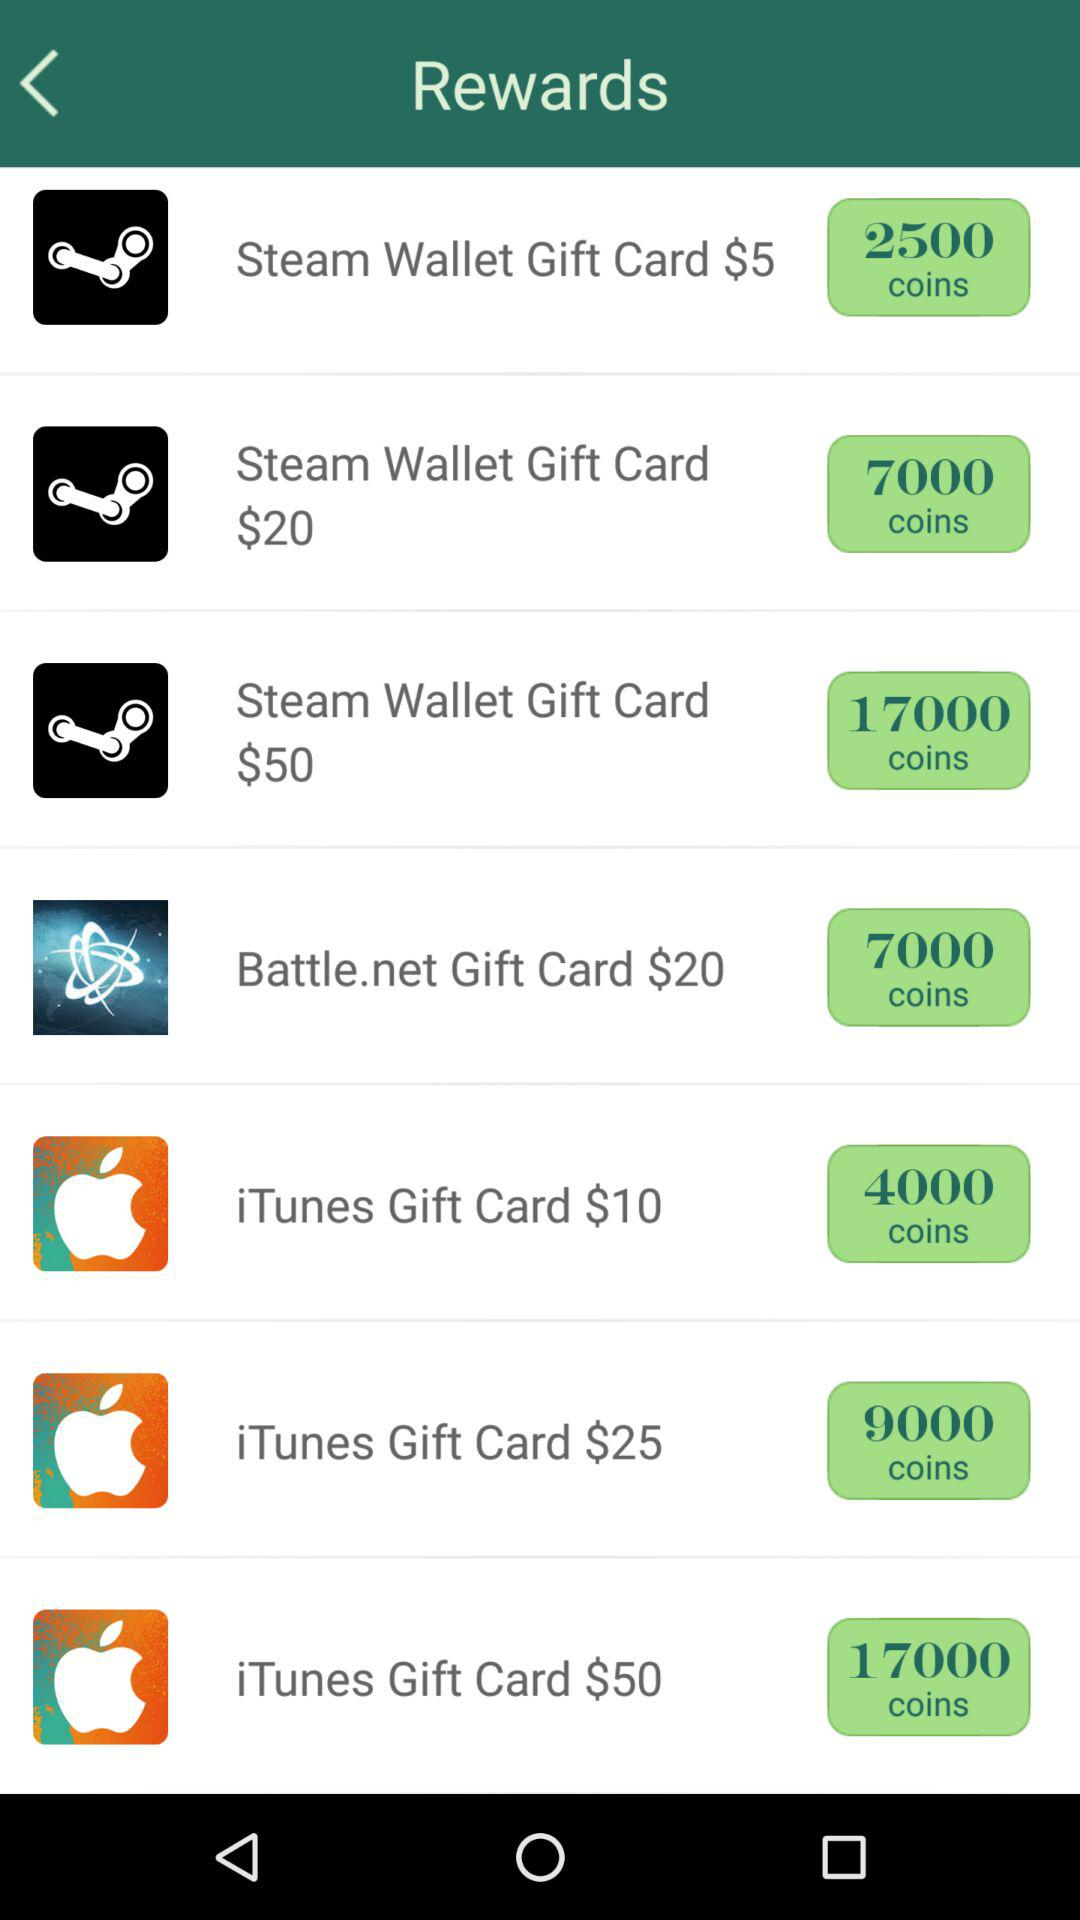How many coins does the user have?
When the provided information is insufficient, respond with <no answer>. <no answer> 